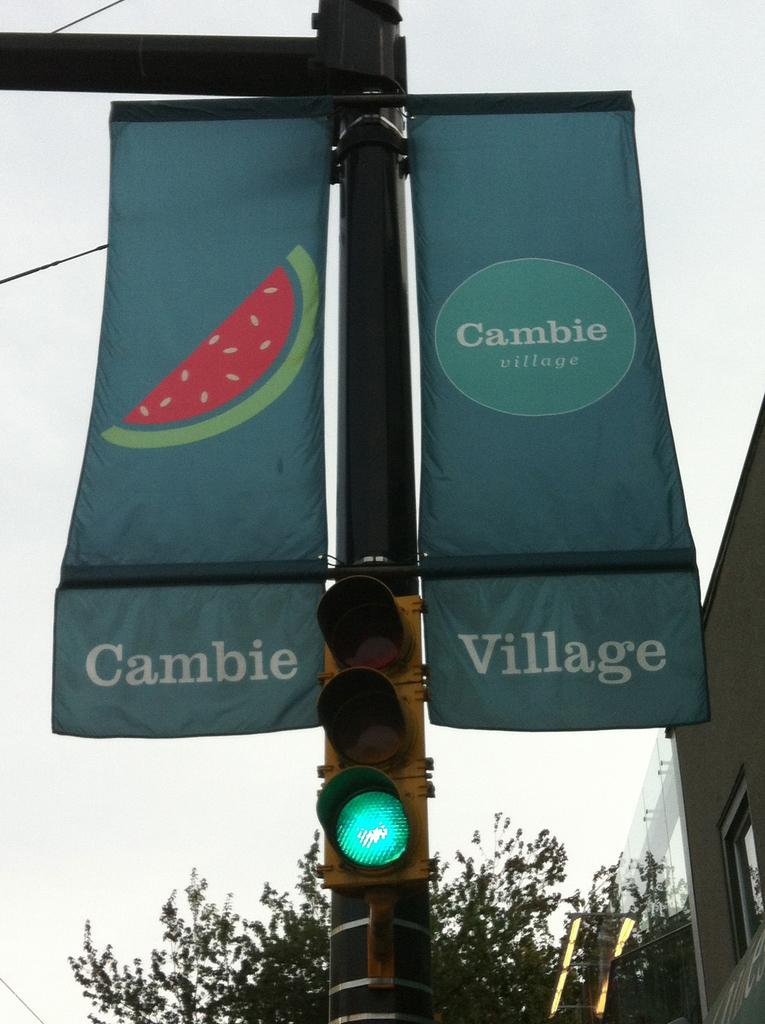<image>
Provide a brief description of the given image. a light that is green and has a cambie village sign above it 